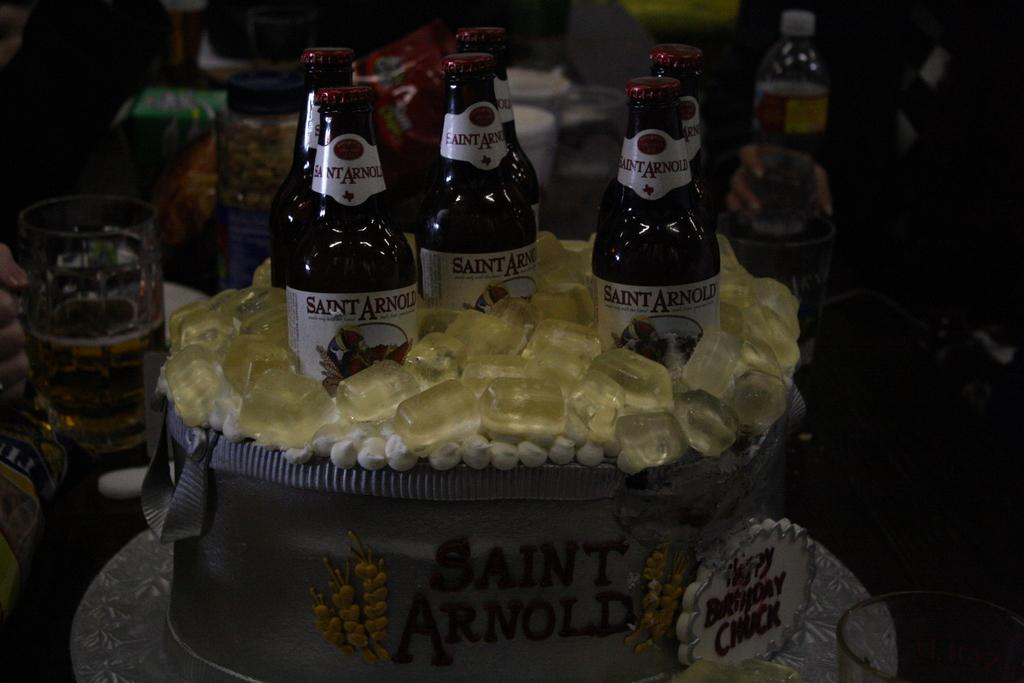How many beer bottles are in the bag in the image? There are six beer bottles in the bag in the image. What is the name of the bag in the image? The bag is labelled as "saint Arnold." What type of art is featured around the beer bottles? There is art representing ice around the beer bottles. What other items related to drinking can be seen in the background of the image? There are glasses and bottles in the background of the image. What type of bells can be heard ringing in the image? There are no bells present in the image, and therefore no sound can be heard. 